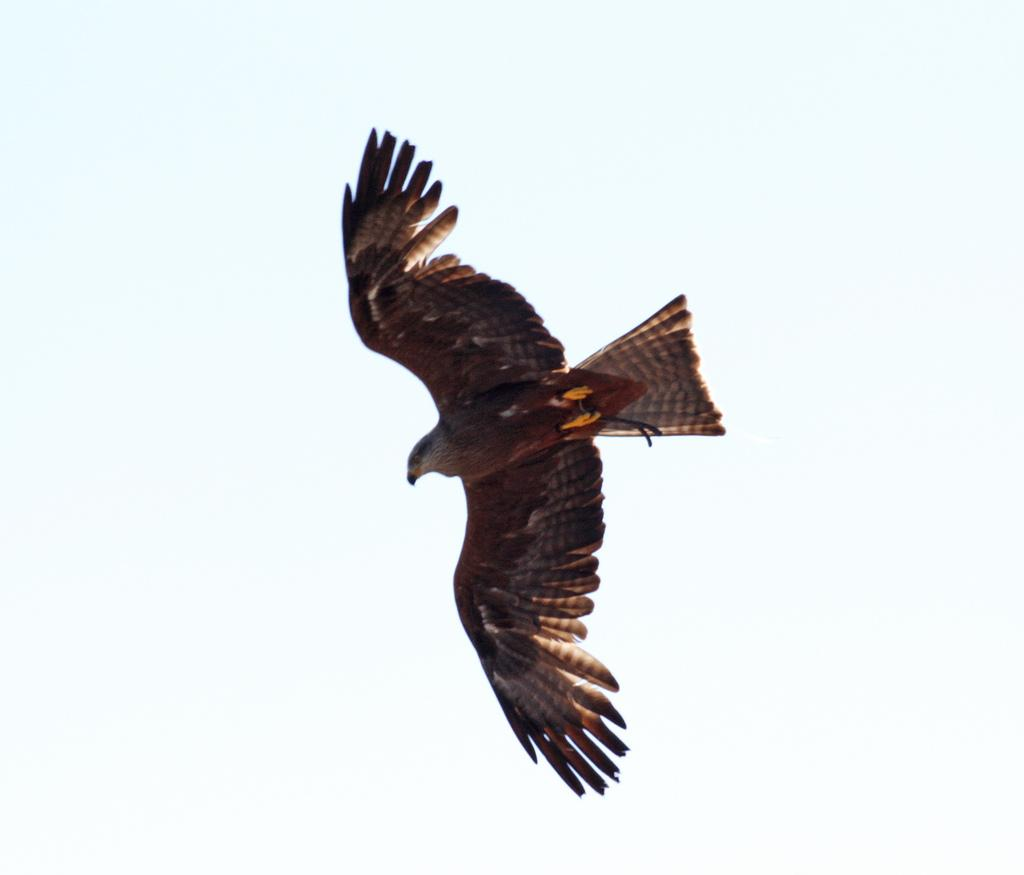What animal can be seen in the image? There is an eagle in the image. What is the eagle doing in the image? The eagle is flying in the sky. Can you see the eagle kissing another bird in the image? There is no kissing or other birds present in the image; it only features an eagle flying in the sky. 